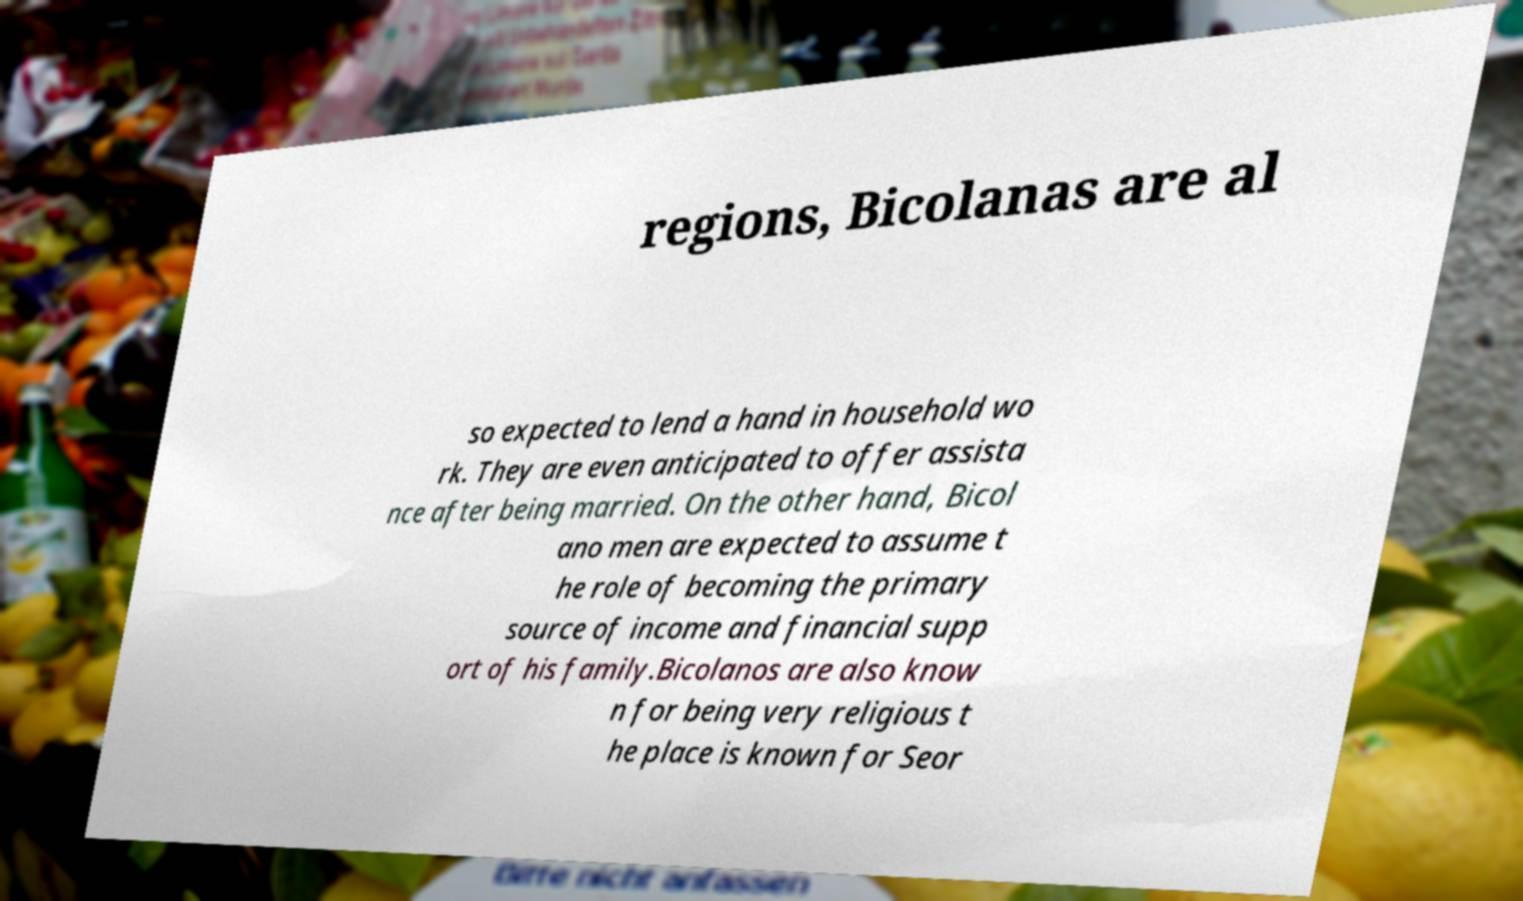Can you read and provide the text displayed in the image?This photo seems to have some interesting text. Can you extract and type it out for me? regions, Bicolanas are al so expected to lend a hand in household wo rk. They are even anticipated to offer assista nce after being married. On the other hand, Bicol ano men are expected to assume t he role of becoming the primary source of income and financial supp ort of his family.Bicolanos are also know n for being very religious t he place is known for Seor 